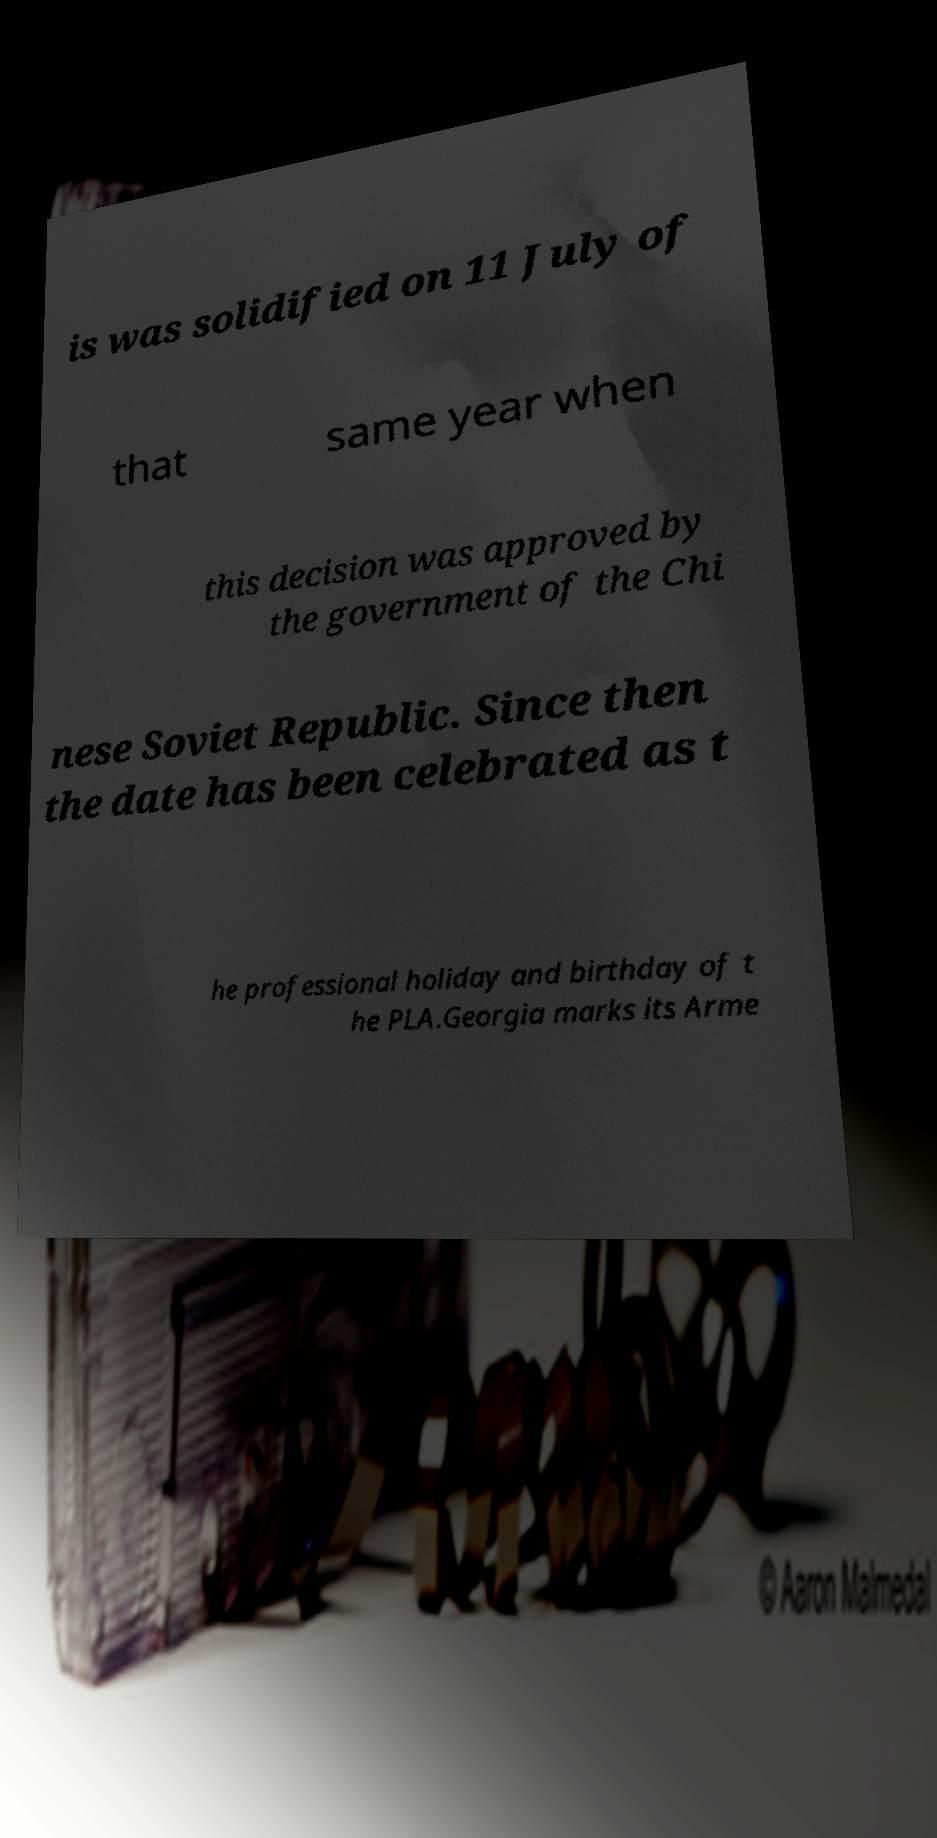I need the written content from this picture converted into text. Can you do that? is was solidified on 11 July of that same year when this decision was approved by the government of the Chi nese Soviet Republic. Since then the date has been celebrated as t he professional holiday and birthday of t he PLA.Georgia marks its Arme 